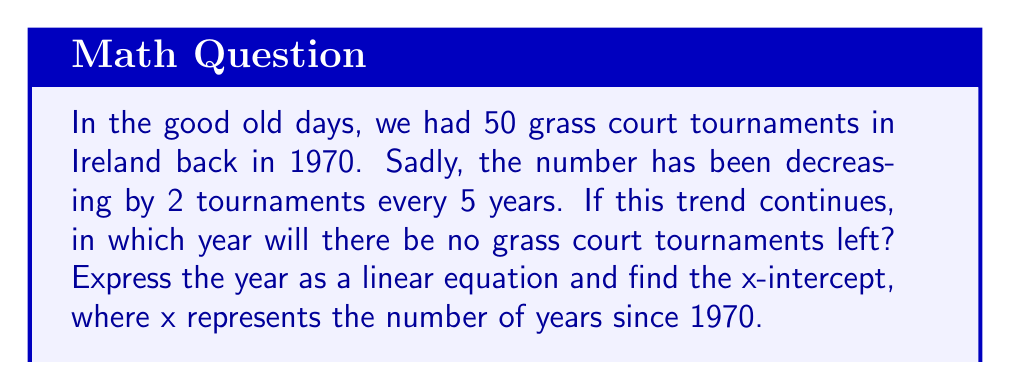Solve this math problem. Let's approach this step-by-step:

1) First, let's define our variables:
   y = number of tournaments
   x = number of years since 1970

2) We can write the equation of the line:
   $$y = 50 - \frac{2}{5}x$$

3) To find the x-intercept, we set y = 0:
   $$0 = 50 - \frac{2}{5}x$$

4) Solve for x:
   $$\frac{2}{5}x = 50$$
   $$x = 50 \cdot \frac{5}{2} = 125$$

5) This means it will take 125 years from 1970 for the number of tournaments to reach zero.

6) To find the actual year, we add 125 to 1970:
   1970 + 125 = 2095

Therefore, if this trend continues, there will be no grass court tournaments left in 2095.
Answer: 2095 